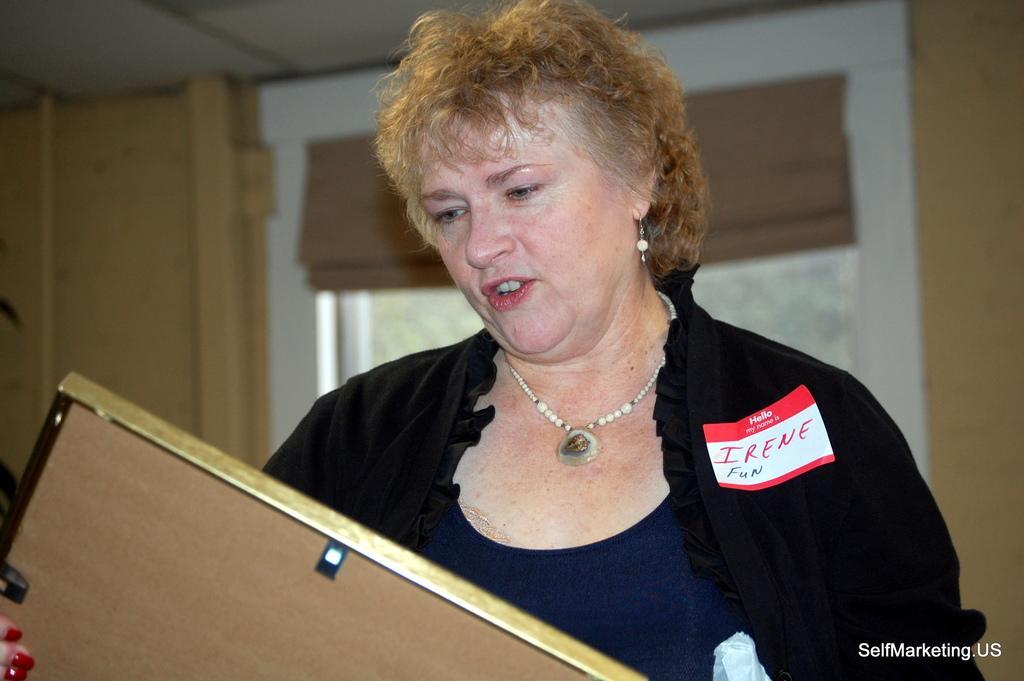Can you describe this image briefly? In this image we can see a woman holding a photo frame. On the backside we can see a window, wall and a roof. 